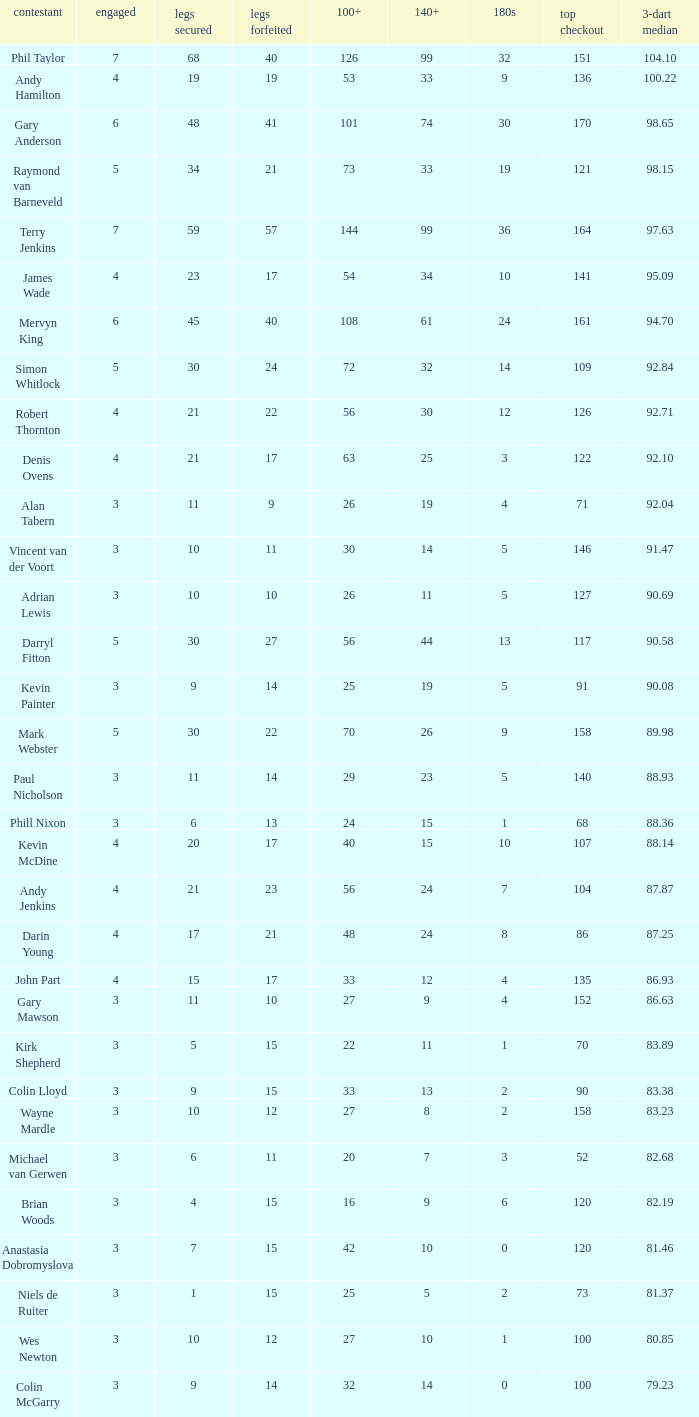What is the total number of 3-dart average when legs lost is larger than 41, and played is larger than 7? 0.0. Would you mind parsing the complete table? {'header': ['contestant', 'engaged', 'legs secured', 'legs forfeited', '100+', '140+', '180s', 'top checkout', '3-dart median'], 'rows': [['Phil Taylor', '7', '68', '40', '126', '99', '32', '151', '104.10'], ['Andy Hamilton', '4', '19', '19', '53', '33', '9', '136', '100.22'], ['Gary Anderson', '6', '48', '41', '101', '74', '30', '170', '98.65'], ['Raymond van Barneveld', '5', '34', '21', '73', '33', '19', '121', '98.15'], ['Terry Jenkins', '7', '59', '57', '144', '99', '36', '164', '97.63'], ['James Wade', '4', '23', '17', '54', '34', '10', '141', '95.09'], ['Mervyn King', '6', '45', '40', '108', '61', '24', '161', '94.70'], ['Simon Whitlock', '5', '30', '24', '72', '32', '14', '109', '92.84'], ['Robert Thornton', '4', '21', '22', '56', '30', '12', '126', '92.71'], ['Denis Ovens', '4', '21', '17', '63', '25', '3', '122', '92.10'], ['Alan Tabern', '3', '11', '9', '26', '19', '4', '71', '92.04'], ['Vincent van der Voort', '3', '10', '11', '30', '14', '5', '146', '91.47'], ['Adrian Lewis', '3', '10', '10', '26', '11', '5', '127', '90.69'], ['Darryl Fitton', '5', '30', '27', '56', '44', '13', '117', '90.58'], ['Kevin Painter', '3', '9', '14', '25', '19', '5', '91', '90.08'], ['Mark Webster', '5', '30', '22', '70', '26', '9', '158', '89.98'], ['Paul Nicholson', '3', '11', '14', '29', '23', '5', '140', '88.93'], ['Phill Nixon', '3', '6', '13', '24', '15', '1', '68', '88.36'], ['Kevin McDine', '4', '20', '17', '40', '15', '10', '107', '88.14'], ['Andy Jenkins', '4', '21', '23', '56', '24', '7', '104', '87.87'], ['Darin Young', '4', '17', '21', '48', '24', '8', '86', '87.25'], ['John Part', '4', '15', '17', '33', '12', '4', '135', '86.93'], ['Gary Mawson', '3', '11', '10', '27', '9', '4', '152', '86.63'], ['Kirk Shepherd', '3', '5', '15', '22', '11', '1', '70', '83.89'], ['Colin Lloyd', '3', '9', '15', '33', '13', '2', '90', '83.38'], ['Wayne Mardle', '3', '10', '12', '27', '8', '2', '158', '83.23'], ['Michael van Gerwen', '3', '6', '11', '20', '7', '3', '52', '82.68'], ['Brian Woods', '3', '4', '15', '16', '9', '6', '120', '82.19'], ['Anastasia Dobromyslova', '3', '7', '15', '42', '10', '0', '120', '81.46'], ['Niels de Ruiter', '3', '1', '15', '25', '5', '2', '73', '81.37'], ['Wes Newton', '3', '10', '12', '27', '10', '1', '100', '80.85'], ['Colin McGarry', '3', '9', '14', '32', '14', '0', '100', '79.23']]} 